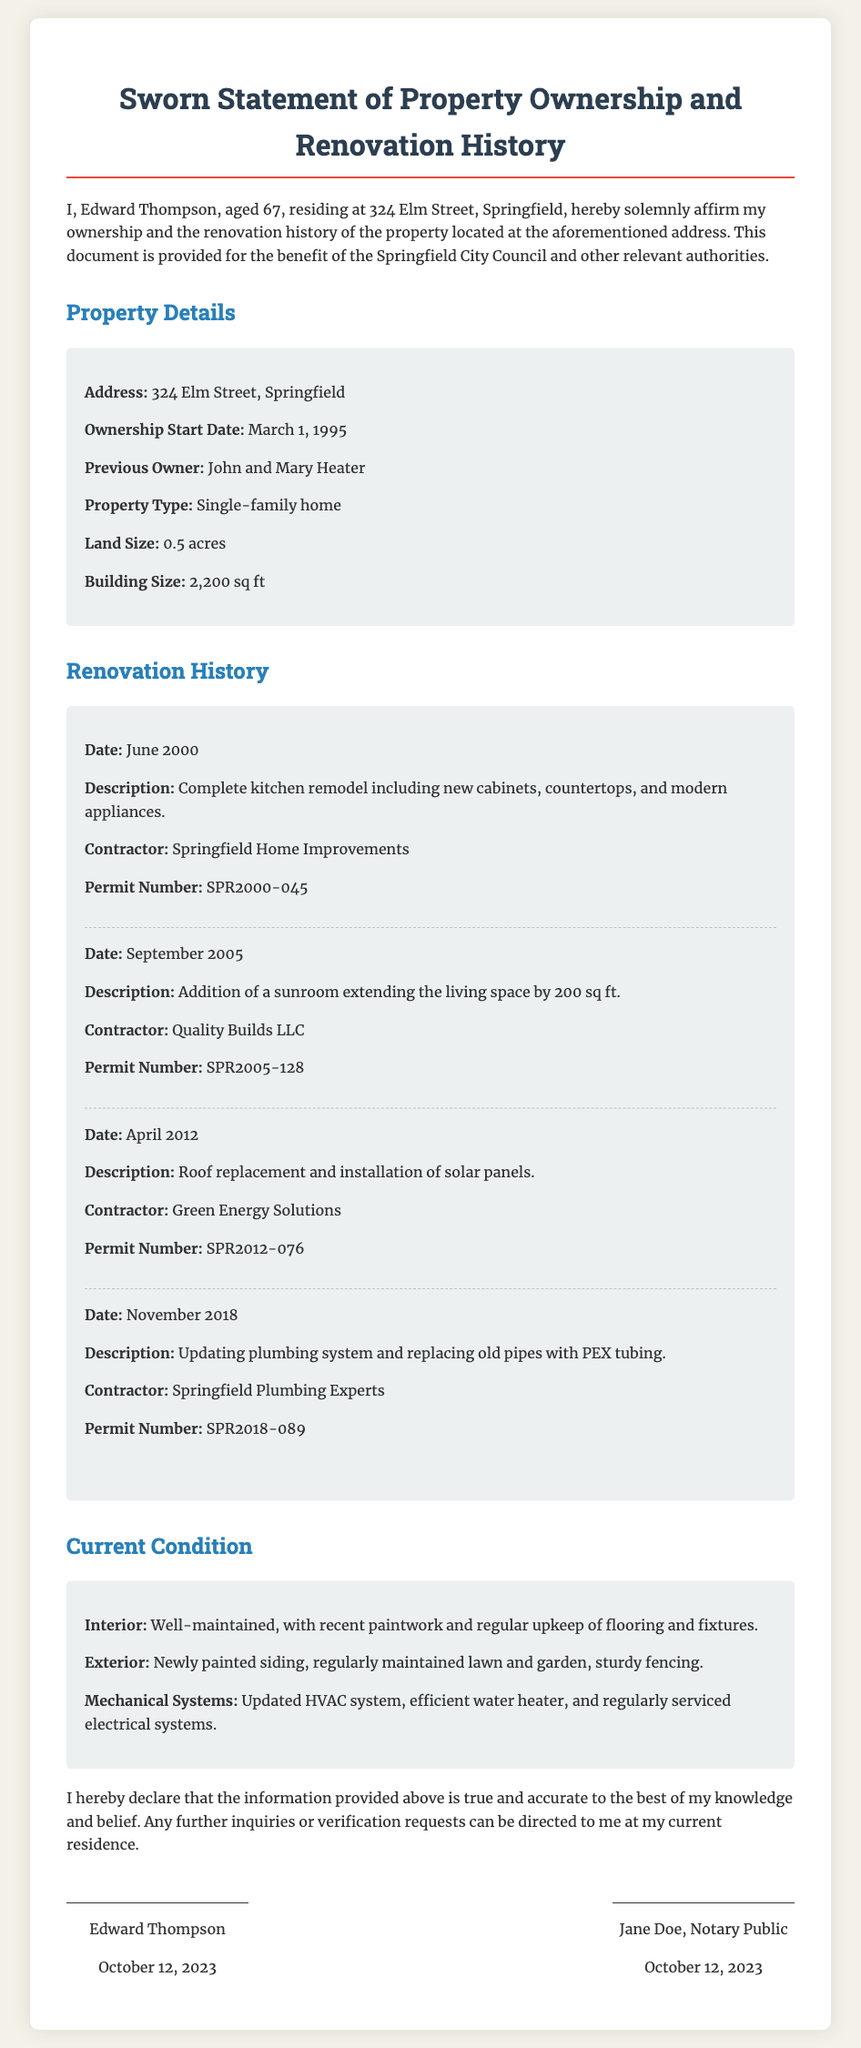What is the name of the property owner? The document states that the property owner is Edward Thompson.
Answer: Edward Thompson What is the address of the property? The address provided is mentioned clearly in the document.
Answer: 324 Elm Street, Springfield When did the ownership start? The document provides a specific date regarding when the ownership began.
Answer: March 1, 1995 How many square feet is the building? The document explicitly states the size of the building.
Answer: 2,200 sq ft What was renovated in June 2000? The document describes the first renovation mention with specific details.
Answer: Complete kitchen remodel What type of property is it? The document categorizes the property type directly.
Answer: Single-family home Who was the previous owner? The document lists the previous owners of the property.
Answer: John and Mary Heater How many renovations are listed in total? The document outlines multiple renovations done over the years, requiring a count of those items.
Answer: Four What is the current condition of the interior? The document provides a short summary of the interior’s condition.
Answer: Well-maintained When was the last renovation completed? The document states the most recent date of renovation.
Answer: November 2018 